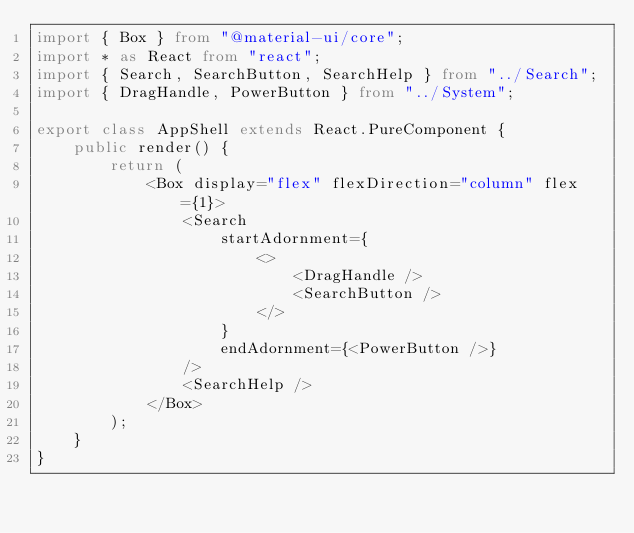Convert code to text. <code><loc_0><loc_0><loc_500><loc_500><_TypeScript_>import { Box } from "@material-ui/core";
import * as React from "react";
import { Search, SearchButton, SearchHelp } from "../Search";
import { DragHandle, PowerButton } from "../System";

export class AppShell extends React.PureComponent {
    public render() {
        return (
            <Box display="flex" flexDirection="column" flex={1}>
                <Search
                    startAdornment={
                        <>
                            <DragHandle />
                            <SearchButton />
                        </>
                    }
                    endAdornment={<PowerButton />}
                />
                <SearchHelp />
            </Box>
        );
    }
}
</code> 